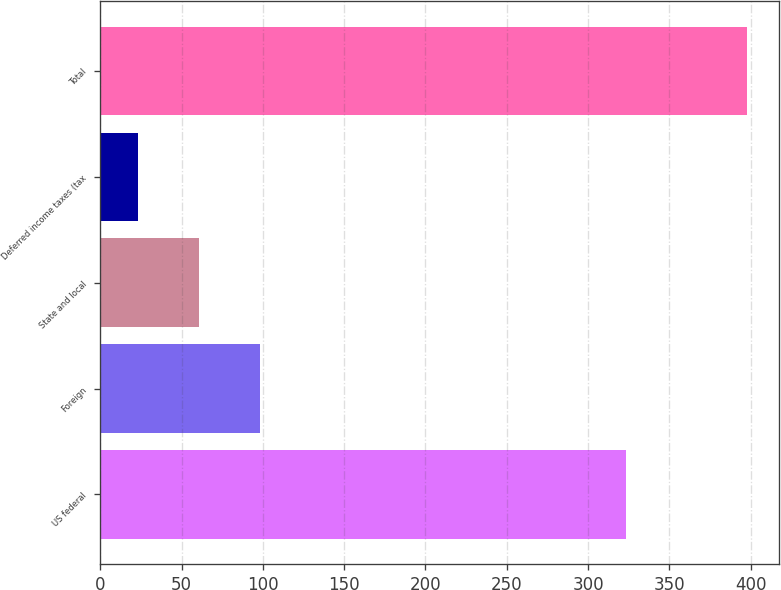Convert chart. <chart><loc_0><loc_0><loc_500><loc_500><bar_chart><fcel>US federal<fcel>Foreign<fcel>State and local<fcel>Deferred income taxes (tax<fcel>Total<nl><fcel>323.4<fcel>98.12<fcel>60.66<fcel>23.2<fcel>397.8<nl></chart> 